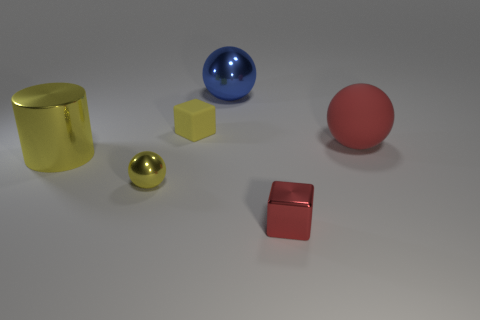Add 1 tiny cyan matte spheres. How many objects exist? 7 Subtract all blocks. How many objects are left? 4 Subtract 0 green cubes. How many objects are left? 6 Subtract all large brown blocks. Subtract all small rubber things. How many objects are left? 5 Add 1 tiny yellow blocks. How many tiny yellow blocks are left? 2 Add 4 blocks. How many blocks exist? 6 